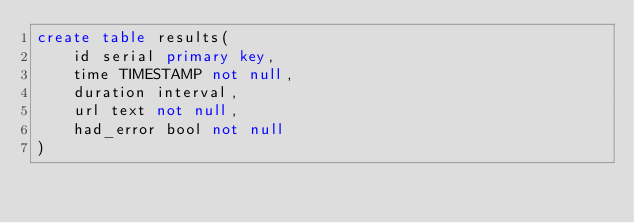Convert code to text. <code><loc_0><loc_0><loc_500><loc_500><_SQL_>create table results(
    id serial primary key,
    time TIMESTAMP not null,
    duration interval,
    url text not null,
    had_error bool not null
)</code> 